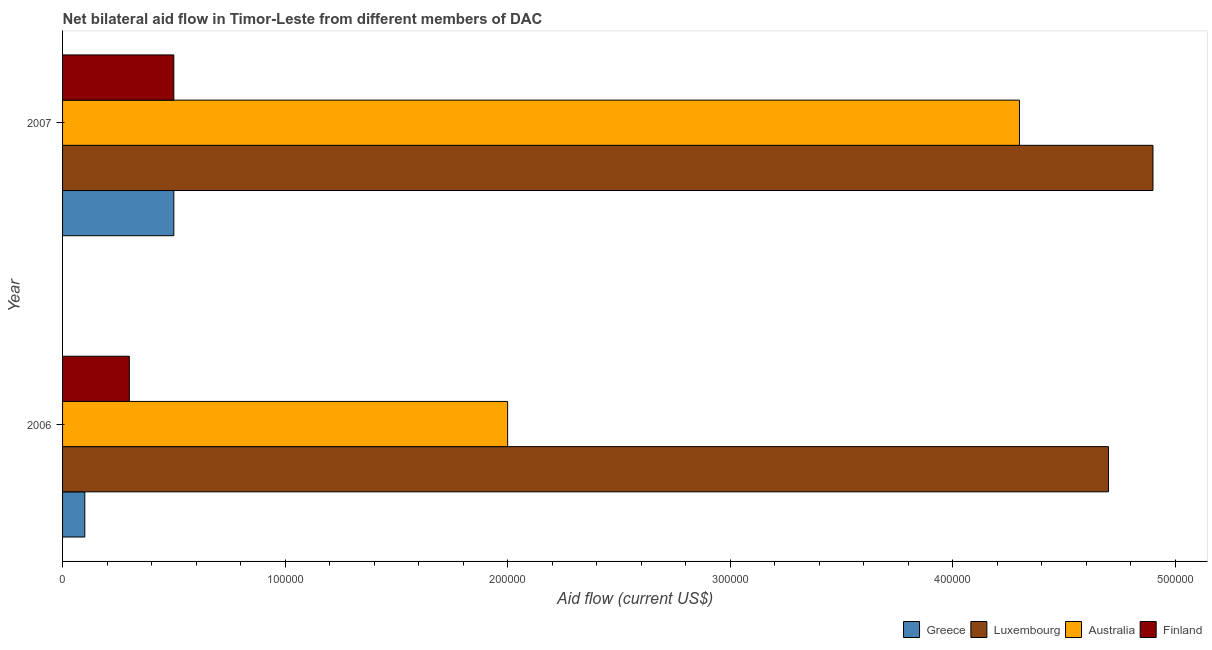How many different coloured bars are there?
Provide a short and direct response. 4. How many groups of bars are there?
Your answer should be very brief. 2. Are the number of bars per tick equal to the number of legend labels?
Keep it short and to the point. Yes. Are the number of bars on each tick of the Y-axis equal?
Keep it short and to the point. Yes. How many bars are there on the 1st tick from the top?
Offer a very short reply. 4. What is the label of the 1st group of bars from the top?
Give a very brief answer. 2007. In how many cases, is the number of bars for a given year not equal to the number of legend labels?
Provide a short and direct response. 0. What is the amount of aid given by australia in 2006?
Keep it short and to the point. 2.00e+05. Across all years, what is the maximum amount of aid given by australia?
Provide a succinct answer. 4.30e+05. Across all years, what is the minimum amount of aid given by finland?
Ensure brevity in your answer.  3.00e+04. In which year was the amount of aid given by greece maximum?
Make the answer very short. 2007. In which year was the amount of aid given by australia minimum?
Make the answer very short. 2006. What is the total amount of aid given by greece in the graph?
Offer a terse response. 6.00e+04. What is the difference between the amount of aid given by australia in 2006 and that in 2007?
Provide a succinct answer. -2.30e+05. What is the difference between the amount of aid given by finland in 2006 and the amount of aid given by australia in 2007?
Give a very brief answer. -4.00e+05. What is the average amount of aid given by finland per year?
Make the answer very short. 4.00e+04. In the year 2007, what is the difference between the amount of aid given by australia and amount of aid given by finland?
Your response must be concise. 3.80e+05. In how many years, is the amount of aid given by greece greater than 340000 US$?
Provide a short and direct response. 0. Is it the case that in every year, the sum of the amount of aid given by australia and amount of aid given by luxembourg is greater than the sum of amount of aid given by greece and amount of aid given by finland?
Your answer should be very brief. Yes. What does the 2nd bar from the top in 2006 represents?
Make the answer very short. Australia. What does the 1st bar from the bottom in 2007 represents?
Offer a very short reply. Greece. How many bars are there?
Your answer should be very brief. 8. Are all the bars in the graph horizontal?
Your response must be concise. Yes. What is the difference between two consecutive major ticks on the X-axis?
Offer a very short reply. 1.00e+05. Where does the legend appear in the graph?
Offer a very short reply. Bottom right. What is the title of the graph?
Offer a very short reply. Net bilateral aid flow in Timor-Leste from different members of DAC. What is the label or title of the X-axis?
Offer a terse response. Aid flow (current US$). What is the label or title of the Y-axis?
Provide a succinct answer. Year. What is the Aid flow (current US$) in Luxembourg in 2006?
Provide a succinct answer. 4.70e+05. What is the Aid flow (current US$) of Australia in 2006?
Offer a very short reply. 2.00e+05. What is the Aid flow (current US$) of Greece in 2007?
Make the answer very short. 5.00e+04. What is the Aid flow (current US$) in Australia in 2007?
Offer a terse response. 4.30e+05. What is the Aid flow (current US$) of Finland in 2007?
Ensure brevity in your answer.  5.00e+04. Across all years, what is the maximum Aid flow (current US$) in Greece?
Your answer should be compact. 5.00e+04. Across all years, what is the maximum Aid flow (current US$) of Australia?
Your response must be concise. 4.30e+05. Across all years, what is the minimum Aid flow (current US$) of Australia?
Offer a terse response. 2.00e+05. Across all years, what is the minimum Aid flow (current US$) of Finland?
Offer a very short reply. 3.00e+04. What is the total Aid flow (current US$) in Luxembourg in the graph?
Your answer should be compact. 9.60e+05. What is the total Aid flow (current US$) of Australia in the graph?
Offer a very short reply. 6.30e+05. What is the total Aid flow (current US$) of Finland in the graph?
Keep it short and to the point. 8.00e+04. What is the difference between the Aid flow (current US$) in Luxembourg in 2006 and that in 2007?
Make the answer very short. -2.00e+04. What is the difference between the Aid flow (current US$) in Australia in 2006 and that in 2007?
Provide a short and direct response. -2.30e+05. What is the difference between the Aid flow (current US$) of Greece in 2006 and the Aid flow (current US$) of Luxembourg in 2007?
Give a very brief answer. -4.80e+05. What is the difference between the Aid flow (current US$) of Greece in 2006 and the Aid flow (current US$) of Australia in 2007?
Your response must be concise. -4.20e+05. What is the difference between the Aid flow (current US$) of Luxembourg in 2006 and the Aid flow (current US$) of Australia in 2007?
Ensure brevity in your answer.  4.00e+04. What is the difference between the Aid flow (current US$) of Luxembourg in 2006 and the Aid flow (current US$) of Finland in 2007?
Give a very brief answer. 4.20e+05. What is the average Aid flow (current US$) in Greece per year?
Offer a very short reply. 3.00e+04. What is the average Aid flow (current US$) of Australia per year?
Your response must be concise. 3.15e+05. What is the average Aid flow (current US$) in Finland per year?
Make the answer very short. 4.00e+04. In the year 2006, what is the difference between the Aid flow (current US$) in Greece and Aid flow (current US$) in Luxembourg?
Provide a short and direct response. -4.60e+05. In the year 2006, what is the difference between the Aid flow (current US$) in Greece and Aid flow (current US$) in Finland?
Offer a terse response. -2.00e+04. In the year 2007, what is the difference between the Aid flow (current US$) of Greece and Aid flow (current US$) of Luxembourg?
Your response must be concise. -4.40e+05. In the year 2007, what is the difference between the Aid flow (current US$) in Greece and Aid flow (current US$) in Australia?
Provide a succinct answer. -3.80e+05. In the year 2007, what is the difference between the Aid flow (current US$) in Luxembourg and Aid flow (current US$) in Australia?
Keep it short and to the point. 6.00e+04. In the year 2007, what is the difference between the Aid flow (current US$) in Luxembourg and Aid flow (current US$) in Finland?
Give a very brief answer. 4.40e+05. What is the ratio of the Aid flow (current US$) of Luxembourg in 2006 to that in 2007?
Ensure brevity in your answer.  0.96. What is the ratio of the Aid flow (current US$) in Australia in 2006 to that in 2007?
Give a very brief answer. 0.47. What is the difference between the highest and the second highest Aid flow (current US$) of Australia?
Offer a terse response. 2.30e+05. What is the difference between the highest and the second highest Aid flow (current US$) in Finland?
Give a very brief answer. 2.00e+04. What is the difference between the highest and the lowest Aid flow (current US$) of Luxembourg?
Your response must be concise. 2.00e+04. What is the difference between the highest and the lowest Aid flow (current US$) of Australia?
Your answer should be very brief. 2.30e+05. 